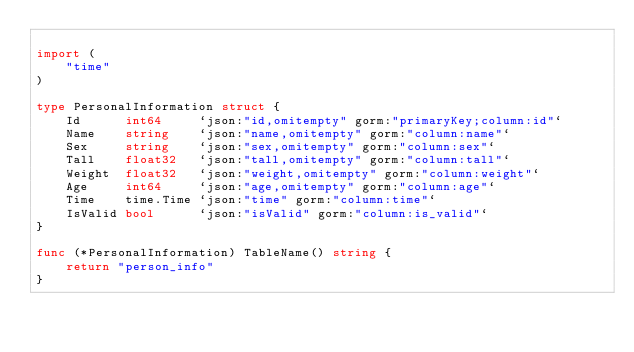<code> <loc_0><loc_0><loc_500><loc_500><_Go_>
import (
	"time"
)

type PersonalInformation struct {
	Id      int64     `json:"id,omitempty" gorm:"primaryKey;column:id"`
	Name    string    `json:"name,omitempty" gorm:"column:name"`
	Sex     string    `json:"sex,omitempty" gorm:"column:sex"`
	Tall    float32   `json:"tall,omitempty" gorm:"column:tall"`
	Weight  float32   `json:"weight,omitempty" gorm:"column:weight"`
	Age     int64     `json:"age,omitempty" gorm:"column:age"`
	Time    time.Time `json:"time" gorm:"column:time"`
	IsValid bool      `json:"isValid" gorm:"column:is_valid"`
}

func (*PersonalInformation) TableName() string {
	return "person_info"
}
</code> 